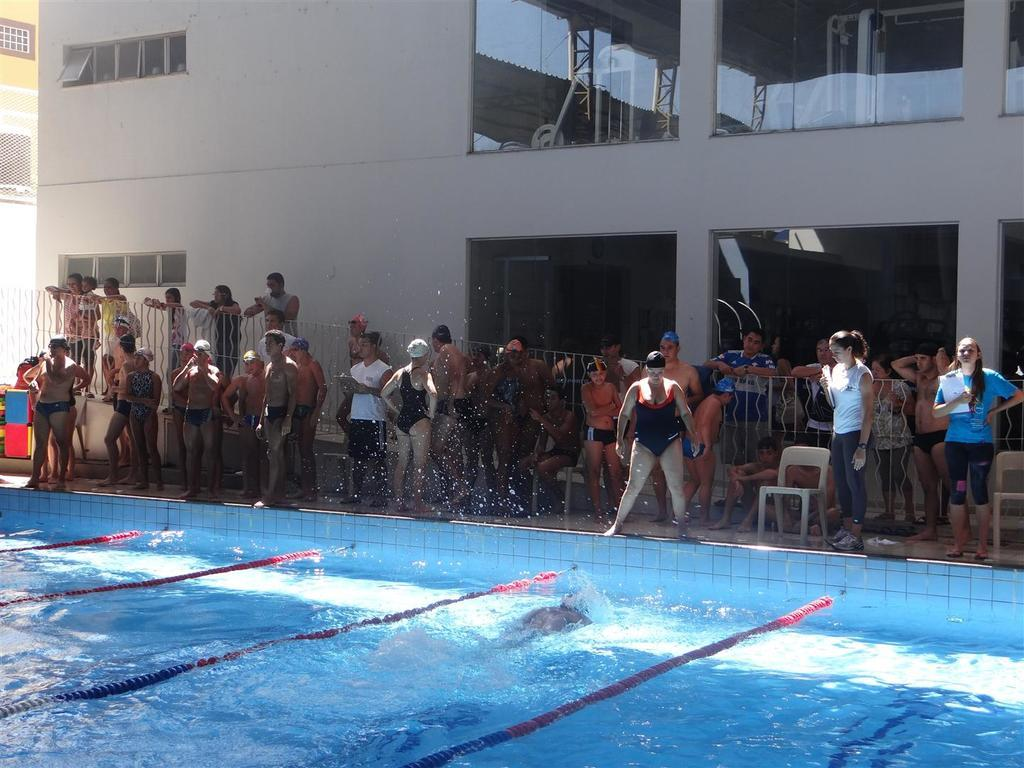What is the main feature of the image? There is a swimming pool in the image. What are the people in the pool doing? There are people swimming in the pool. What are the people near the pool doing? These people are standing near the pool and watching the swimmers. What type of seating is available in the image? There are chairs visible in the image. What can be seen in the distance in the image? There are buildings in the background of the image. Can you see any notes floating on the surface of the lake in the image? There is no lake present in the image; it features a swimming pool. Is there any steam coming from the water in the image? There is no steam visible in the image, as it features a swimming pool with people swimming and standing nearby. 